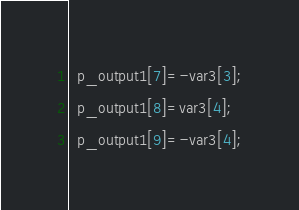Convert code to text. <code><loc_0><loc_0><loc_500><loc_500><_C++_>  p_output1[7]=-var3[3];
  p_output1[8]=var3[4];
  p_output1[9]=-var3[4];</code> 